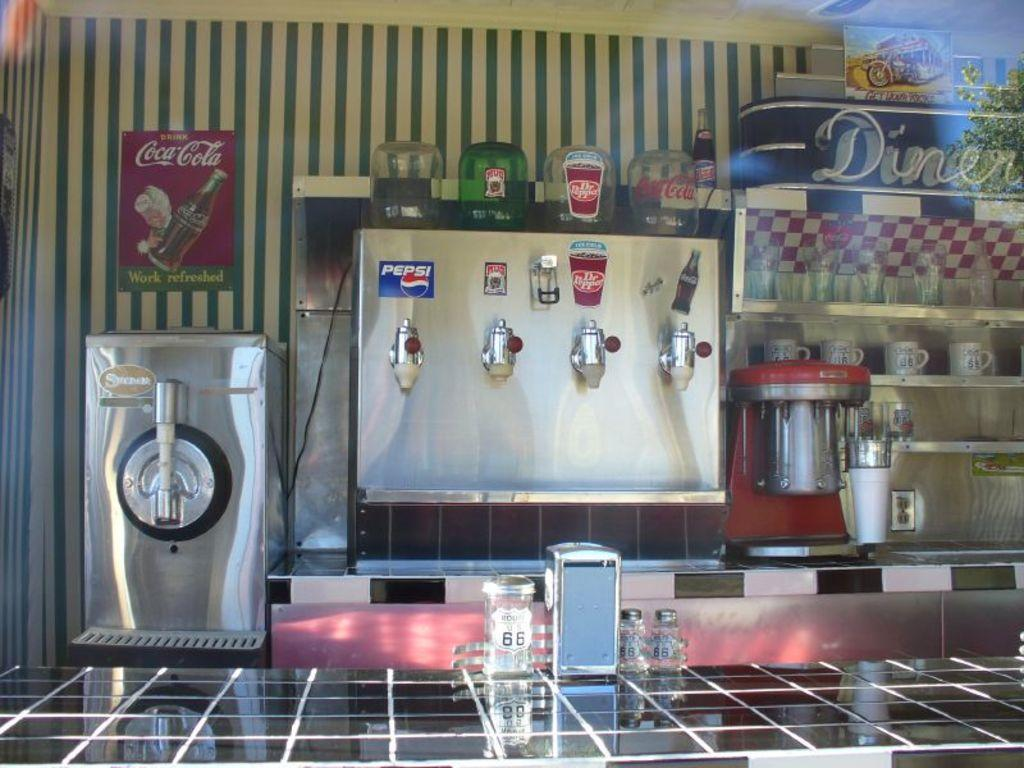<image>
Write a terse but informative summary of the picture. Pepsi is one of several drinks available at this establishment. 